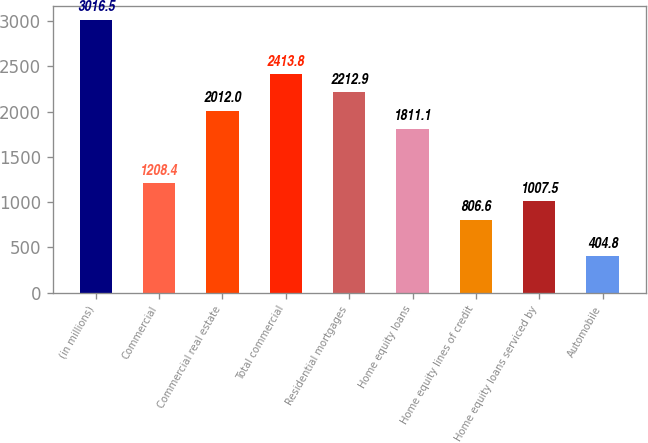Convert chart to OTSL. <chart><loc_0><loc_0><loc_500><loc_500><bar_chart><fcel>(in millions)<fcel>Commercial<fcel>Commercial real estate<fcel>Total commercial<fcel>Residential mortgages<fcel>Home equity loans<fcel>Home equity lines of credit<fcel>Home equity loans serviced by<fcel>Automobile<nl><fcel>3016.5<fcel>1208.4<fcel>2012<fcel>2413.8<fcel>2212.9<fcel>1811.1<fcel>806.6<fcel>1007.5<fcel>404.8<nl></chart> 